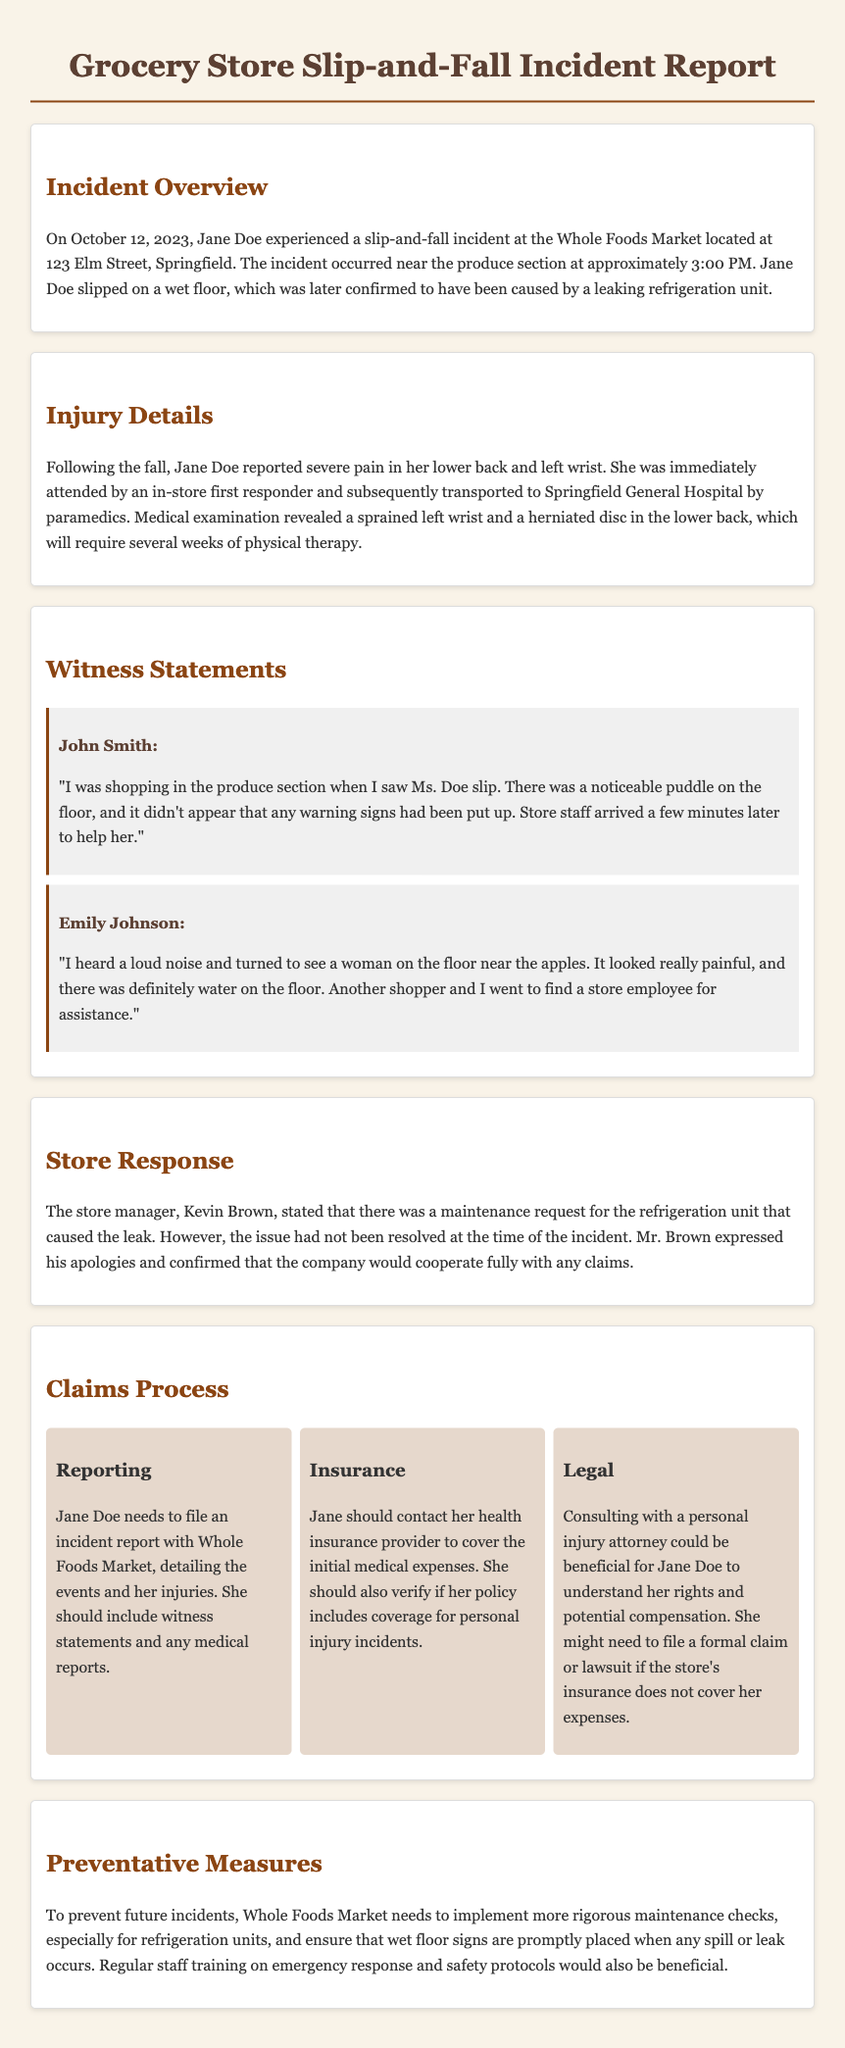What is the date of the incident? The date of the incident is specifically mentioned in the document as October 12, 2023.
Answer: October 12, 2023 What was the location of the slip-and-fall incident? The incident report states that it occurred at Whole Foods Market located at 123 Elm Street, Springfield.
Answer: Whole Foods Market, 123 Elm Street, Springfield What time did the incident occur? The document specifies that the incident happened at approximately 3:00 PM.
Answer: 3:00 PM What injuries did Jane Doe report? The document mentions that she reported severe pain in her lower back and left wrist, with specific injuries being a sprained wrist and a herniated disc.
Answer: Sprained left wrist and herniated disc Who witnessed the incident? The report includes witness statements from John Smith and Emily Johnson regarding the slip-and-fall accident.
Answer: John Smith and Emily Johnson What is the first step in the claims process for Jane Doe? The claims process section indicates that Jane needs to file an incident report with Whole Foods Market detailing the events and injuries.
Answer: File an incident report What should Jane Doe contact her health insurance provider for? The document advises Jane to contact her health insurance provider to cover initial medical expenses and verify personal injury coverage.
Answer: Cover initial medical expenses What preventative measure does the report suggest for the store? To prevent future incidents, the report states that the store needs to implement more rigorous maintenance checks, especially for refrigeration units.
Answer: Implement more rigorous maintenance checks 